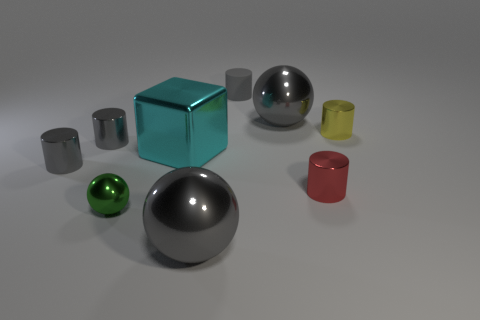Are there any tiny green balls?
Make the answer very short. Yes. There is a big object in front of the red metallic cylinder; what color is it?
Offer a very short reply. Gray. How many other things are made of the same material as the block?
Ensure brevity in your answer.  7. The object that is both to the right of the tiny matte cylinder and behind the yellow metal object is what color?
Keep it short and to the point. Gray. How many things are either cylinders left of the cyan block or small objects?
Make the answer very short. 6. How many other things are the same color as the rubber object?
Your answer should be very brief. 4. Is the number of metallic objects to the left of the rubber object the same as the number of small shiny things?
Your answer should be compact. Yes. There is a gray sphere that is right of the small rubber cylinder that is behind the big metallic cube; how many large metal cubes are to the right of it?
Your answer should be compact. 0. There is a red cylinder; is it the same size as the gray metallic cylinder in front of the cyan block?
Your answer should be very brief. Yes. How many tiny cyan matte cubes are there?
Give a very brief answer. 0. 